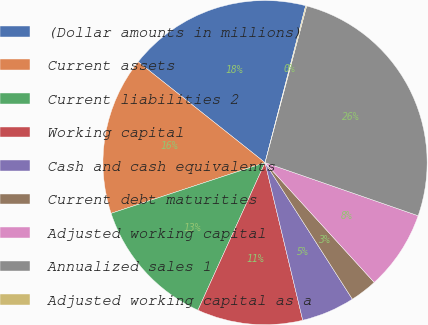Convert chart. <chart><loc_0><loc_0><loc_500><loc_500><pie_chart><fcel>(Dollar amounts in millions)<fcel>Current assets<fcel>Current liabilities 2<fcel>Working capital<fcel>Cash and cash equivalents<fcel>Current debt maturities<fcel>Adjusted working capital<fcel>Annualized sales 1<fcel>Adjusted working capital as a<nl><fcel>18.35%<fcel>15.75%<fcel>13.14%<fcel>10.53%<fcel>5.32%<fcel>2.71%<fcel>7.92%<fcel>26.18%<fcel>0.1%<nl></chart> 